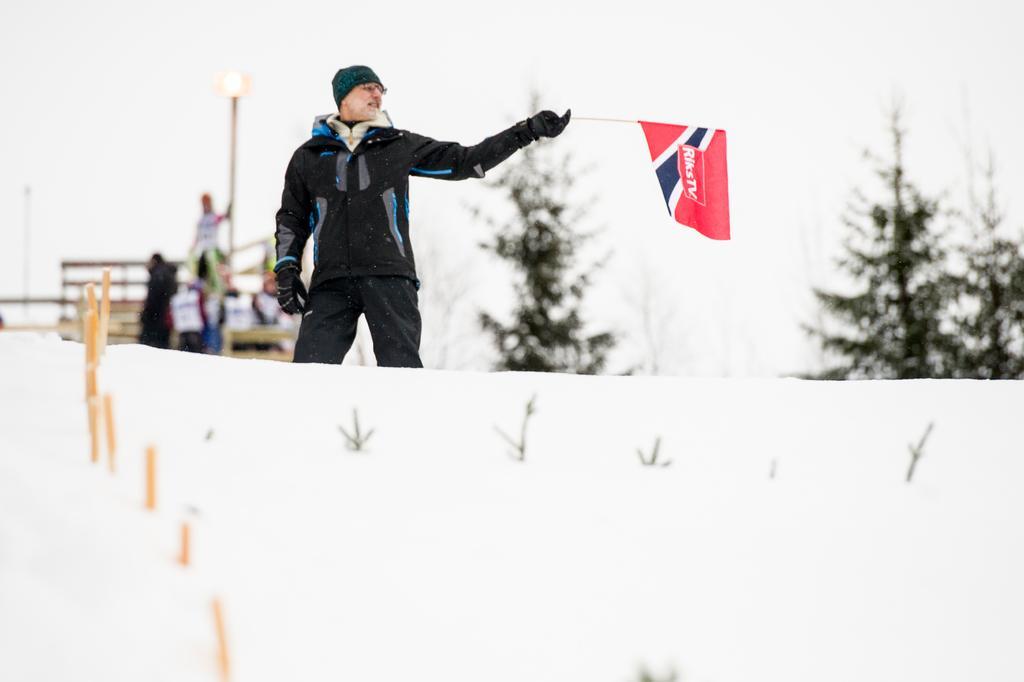Please provide a concise description of this image. The man in the middle of the picture wearing black jacket and green cap is holding a red color cap in his hand. At the bottom of the picture, we see ice. Behind him, we see people standing beside the vehicle. In the background, there are trees. It is blurred in the background. 